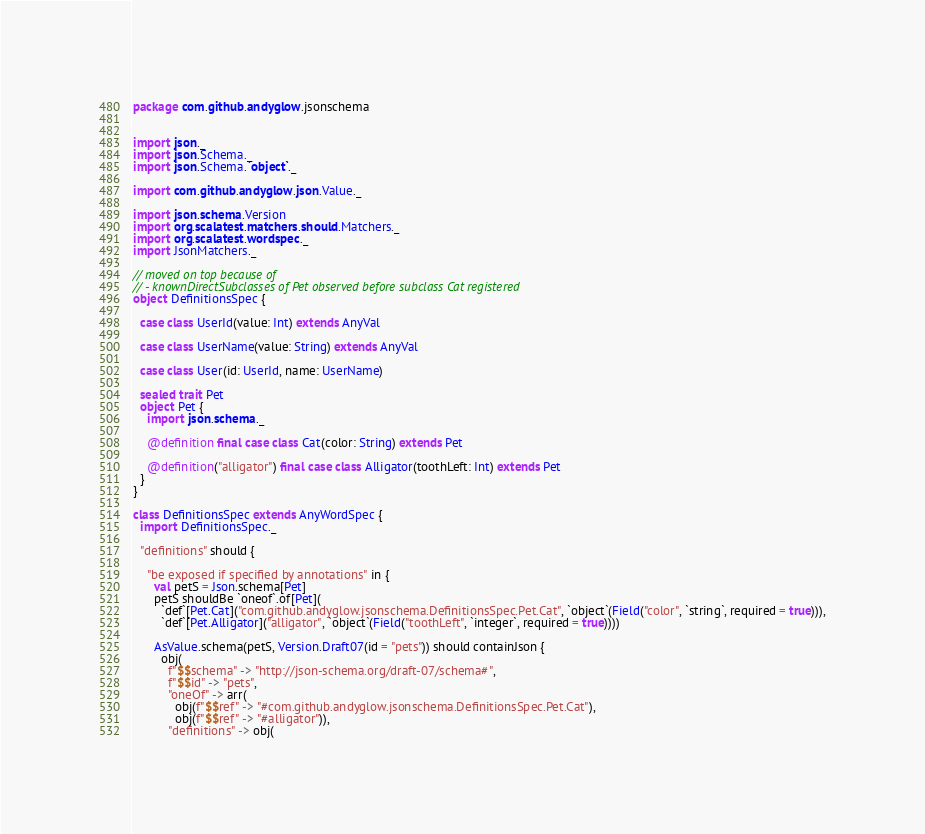Convert code to text. <code><loc_0><loc_0><loc_500><loc_500><_Scala_>package com.github.andyglow.jsonschema


import json._
import json.Schema._
import json.Schema.`object`._

import com.github.andyglow.json.Value._

import json.schema.Version
import org.scalatest.matchers.should.Matchers._
import org.scalatest.wordspec._
import JsonMatchers._

// moved on top because of
// - knownDirectSubclasses of Pet observed before subclass Cat registered
object DefinitionsSpec {

  case class UserId(value: Int) extends AnyVal

  case class UserName(value: String) extends AnyVal

  case class User(id: UserId, name: UserName)

  sealed trait Pet
  object Pet {
    import json.schema._

    @definition final case class Cat(color: String) extends Pet

    @definition("alligator") final case class Alligator(toothLeft: Int) extends Pet
  }
}

class DefinitionsSpec extends AnyWordSpec {
  import DefinitionsSpec._

  "definitions" should {

    "be exposed if specified by annotations" in {
      val petS = Json.schema[Pet]
      petS shouldBe `oneof`.of[Pet](
        `def`[Pet.Cat]("com.github.andyglow.jsonschema.DefinitionsSpec.Pet.Cat", `object`(Field("color", `string`, required = true))),
        `def`[Pet.Alligator]("alligator", `object`(Field("toothLeft", `integer`, required = true))))

      AsValue.schema(petS, Version.Draft07(id = "pets")) should containJson {
        obj(
          f"$$schema" -> "http://json-schema.org/draft-07/schema#",
          f"$$id" -> "pets",
          "oneOf" -> arr(
            obj(f"$$ref" -> "#com.github.andyglow.jsonschema.DefinitionsSpec.Pet.Cat"),
            obj(f"$$ref" -> "#alligator")),
          "definitions" -> obj(</code> 